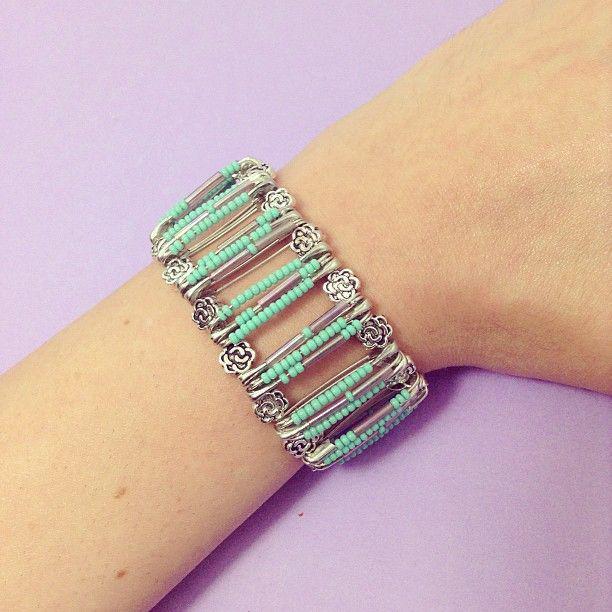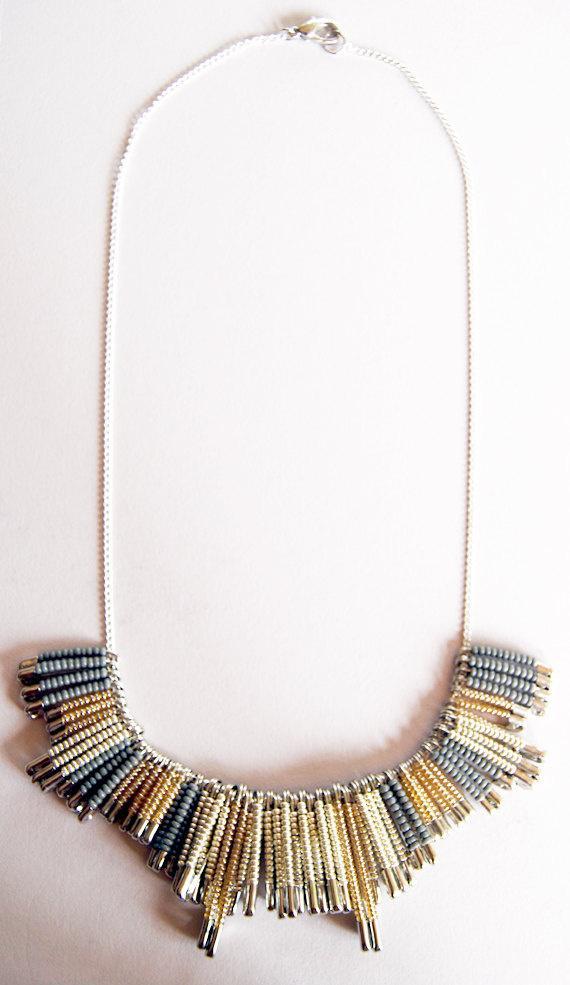The first image is the image on the left, the second image is the image on the right. Examine the images to the left and right. Is the description "One image shows a row of six safety pins, each with a different color top, and with one of the pins open on the end" accurate? Answer yes or no. No. 